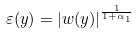<formula> <loc_0><loc_0><loc_500><loc_500>\varepsilon ( y ) = \left | w ( y ) \right | ^ { \frac { 1 } { 1 + \alpha _ { 1 } } }</formula> 